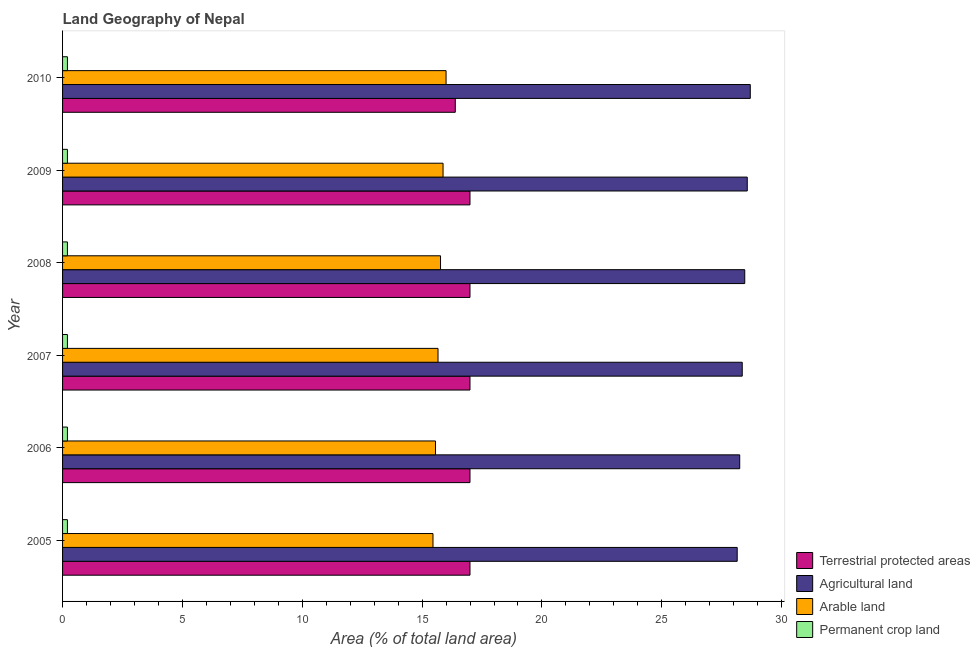How many different coloured bars are there?
Offer a very short reply. 4. Are the number of bars per tick equal to the number of legend labels?
Your answer should be very brief. Yes. Are the number of bars on each tick of the Y-axis equal?
Give a very brief answer. Yes. In how many cases, is the number of bars for a given year not equal to the number of legend labels?
Offer a very short reply. 0. What is the percentage of area under agricultural land in 2009?
Your response must be concise. 28.57. Across all years, what is the maximum percentage of area under permanent crop land?
Provide a succinct answer. 0.2. Across all years, what is the minimum percentage of area under arable land?
Your answer should be very brief. 15.45. In which year was the percentage of area under agricultural land maximum?
Your answer should be very brief. 2010. In which year was the percentage of area under arable land minimum?
Your answer should be very brief. 2005. What is the total percentage of land under terrestrial protection in the graph?
Keep it short and to the point. 101.37. What is the difference between the percentage of area under permanent crop land in 2005 and that in 2009?
Your response must be concise. 0. What is the difference between the percentage of area under agricultural land in 2010 and the percentage of area under arable land in 2009?
Your answer should be compact. 12.82. What is the average percentage of area under agricultural land per year?
Your answer should be compact. 28.41. In the year 2006, what is the difference between the percentage of area under agricultural land and percentage of area under permanent crop land?
Provide a short and direct response. 28.05. Is the percentage of area under agricultural land in 2005 less than that in 2010?
Give a very brief answer. Yes. Is the difference between the percentage of land under terrestrial protection in 2007 and 2009 greater than the difference between the percentage of area under agricultural land in 2007 and 2009?
Make the answer very short. Yes. What is the difference between the highest and the second highest percentage of area under agricultural land?
Give a very brief answer. 0.13. What is the difference between the highest and the lowest percentage of land under terrestrial protection?
Your answer should be very brief. 0.61. What does the 3rd bar from the top in 2006 represents?
Offer a very short reply. Agricultural land. What does the 2nd bar from the bottom in 2007 represents?
Keep it short and to the point. Agricultural land. How many bars are there?
Keep it short and to the point. 24. How many years are there in the graph?
Your answer should be very brief. 6. What is the difference between two consecutive major ticks on the X-axis?
Give a very brief answer. 5. Does the graph contain grids?
Provide a succinct answer. No. How are the legend labels stacked?
Make the answer very short. Vertical. What is the title of the graph?
Provide a succinct answer. Land Geography of Nepal. Does "Burnt food" appear as one of the legend labels in the graph?
Offer a very short reply. No. What is the label or title of the X-axis?
Your answer should be compact. Area (% of total land area). What is the label or title of the Y-axis?
Offer a very short reply. Year. What is the Area (% of total land area) in Terrestrial protected areas in 2005?
Your answer should be very brief. 17. What is the Area (% of total land area) in Agricultural land in 2005?
Your answer should be very brief. 28.15. What is the Area (% of total land area) of Arable land in 2005?
Offer a very short reply. 15.45. What is the Area (% of total land area) of Permanent crop land in 2005?
Offer a very short reply. 0.2. What is the Area (% of total land area) in Terrestrial protected areas in 2006?
Make the answer very short. 17. What is the Area (% of total land area) of Agricultural land in 2006?
Your answer should be very brief. 28.25. What is the Area (% of total land area) in Arable land in 2006?
Ensure brevity in your answer.  15.56. What is the Area (% of total land area) of Permanent crop land in 2006?
Ensure brevity in your answer.  0.2. What is the Area (% of total land area) in Terrestrial protected areas in 2007?
Ensure brevity in your answer.  17. What is the Area (% of total land area) in Agricultural land in 2007?
Your response must be concise. 28.36. What is the Area (% of total land area) in Arable land in 2007?
Offer a very short reply. 15.66. What is the Area (% of total land area) in Permanent crop land in 2007?
Your answer should be very brief. 0.2. What is the Area (% of total land area) in Terrestrial protected areas in 2008?
Provide a succinct answer. 17. What is the Area (% of total land area) in Agricultural land in 2008?
Make the answer very short. 28.46. What is the Area (% of total land area) in Arable land in 2008?
Provide a short and direct response. 15.77. What is the Area (% of total land area) in Permanent crop land in 2008?
Offer a terse response. 0.2. What is the Area (% of total land area) of Terrestrial protected areas in 2009?
Provide a short and direct response. 17. What is the Area (% of total land area) in Agricultural land in 2009?
Provide a succinct answer. 28.57. What is the Area (% of total land area) of Arable land in 2009?
Offer a very short reply. 15.87. What is the Area (% of total land area) in Permanent crop land in 2009?
Ensure brevity in your answer.  0.2. What is the Area (% of total land area) of Terrestrial protected areas in 2010?
Make the answer very short. 16.38. What is the Area (% of total land area) of Agricultural land in 2010?
Your response must be concise. 28.69. What is the Area (% of total land area) in Arable land in 2010?
Your answer should be compact. 16. What is the Area (% of total land area) of Permanent crop land in 2010?
Make the answer very short. 0.2. Across all years, what is the maximum Area (% of total land area) of Terrestrial protected areas?
Make the answer very short. 17. Across all years, what is the maximum Area (% of total land area) of Agricultural land?
Offer a very short reply. 28.69. Across all years, what is the maximum Area (% of total land area) in Permanent crop land?
Your response must be concise. 0.2. Across all years, what is the minimum Area (% of total land area) in Terrestrial protected areas?
Provide a short and direct response. 16.38. Across all years, what is the minimum Area (% of total land area) of Agricultural land?
Ensure brevity in your answer.  28.15. Across all years, what is the minimum Area (% of total land area) of Arable land?
Provide a short and direct response. 15.45. Across all years, what is the minimum Area (% of total land area) in Permanent crop land?
Offer a terse response. 0.2. What is the total Area (% of total land area) in Terrestrial protected areas in the graph?
Your answer should be compact. 101.37. What is the total Area (% of total land area) of Agricultural land in the graph?
Make the answer very short. 170.48. What is the total Area (% of total land area) of Arable land in the graph?
Give a very brief answer. 94.32. What is the total Area (% of total land area) in Permanent crop land in the graph?
Ensure brevity in your answer.  1.22. What is the difference between the Area (% of total land area) of Terrestrial protected areas in 2005 and that in 2006?
Offer a terse response. 0. What is the difference between the Area (% of total land area) of Agricultural land in 2005 and that in 2006?
Provide a short and direct response. -0.1. What is the difference between the Area (% of total land area) of Arable land in 2005 and that in 2006?
Your answer should be very brief. -0.1. What is the difference between the Area (% of total land area) in Permanent crop land in 2005 and that in 2006?
Ensure brevity in your answer.  0. What is the difference between the Area (% of total land area) in Terrestrial protected areas in 2005 and that in 2007?
Your answer should be compact. 0. What is the difference between the Area (% of total land area) in Agricultural land in 2005 and that in 2007?
Give a very brief answer. -0.21. What is the difference between the Area (% of total land area) of Arable land in 2005 and that in 2007?
Offer a terse response. -0.21. What is the difference between the Area (% of total land area) of Permanent crop land in 2005 and that in 2007?
Give a very brief answer. 0. What is the difference between the Area (% of total land area) of Terrestrial protected areas in 2005 and that in 2008?
Offer a very short reply. 0. What is the difference between the Area (% of total land area) in Agricultural land in 2005 and that in 2008?
Give a very brief answer. -0.31. What is the difference between the Area (% of total land area) in Arable land in 2005 and that in 2008?
Make the answer very short. -0.31. What is the difference between the Area (% of total land area) in Permanent crop land in 2005 and that in 2008?
Give a very brief answer. 0. What is the difference between the Area (% of total land area) in Terrestrial protected areas in 2005 and that in 2009?
Offer a very short reply. 0. What is the difference between the Area (% of total land area) in Agricultural land in 2005 and that in 2009?
Give a very brief answer. -0.42. What is the difference between the Area (% of total land area) in Arable land in 2005 and that in 2009?
Your answer should be compact. -0.42. What is the difference between the Area (% of total land area) of Terrestrial protected areas in 2005 and that in 2010?
Your answer should be very brief. 0.61. What is the difference between the Area (% of total land area) in Agricultural land in 2005 and that in 2010?
Ensure brevity in your answer.  -0.55. What is the difference between the Area (% of total land area) in Arable land in 2005 and that in 2010?
Your answer should be compact. -0.55. What is the difference between the Area (% of total land area) of Permanent crop land in 2005 and that in 2010?
Your answer should be very brief. 0. What is the difference between the Area (% of total land area) in Agricultural land in 2006 and that in 2007?
Ensure brevity in your answer.  -0.1. What is the difference between the Area (% of total land area) of Arable land in 2006 and that in 2007?
Your answer should be compact. -0.1. What is the difference between the Area (% of total land area) in Permanent crop land in 2006 and that in 2007?
Offer a terse response. 0. What is the difference between the Area (% of total land area) in Terrestrial protected areas in 2006 and that in 2008?
Ensure brevity in your answer.  0. What is the difference between the Area (% of total land area) in Agricultural land in 2006 and that in 2008?
Your answer should be very brief. -0.21. What is the difference between the Area (% of total land area) in Arable land in 2006 and that in 2008?
Your answer should be compact. -0.21. What is the difference between the Area (% of total land area) of Terrestrial protected areas in 2006 and that in 2009?
Your answer should be compact. 0. What is the difference between the Area (% of total land area) in Agricultural land in 2006 and that in 2009?
Offer a very short reply. -0.31. What is the difference between the Area (% of total land area) of Arable land in 2006 and that in 2009?
Your response must be concise. -0.31. What is the difference between the Area (% of total land area) in Terrestrial protected areas in 2006 and that in 2010?
Your answer should be compact. 0.61. What is the difference between the Area (% of total land area) of Agricultural land in 2006 and that in 2010?
Make the answer very short. -0.44. What is the difference between the Area (% of total land area) of Arable land in 2006 and that in 2010?
Your answer should be very brief. -0.44. What is the difference between the Area (% of total land area) of Permanent crop land in 2006 and that in 2010?
Offer a terse response. 0. What is the difference between the Area (% of total land area) of Terrestrial protected areas in 2007 and that in 2008?
Your answer should be compact. 0. What is the difference between the Area (% of total land area) in Agricultural land in 2007 and that in 2008?
Make the answer very short. -0.1. What is the difference between the Area (% of total land area) in Arable land in 2007 and that in 2008?
Your response must be concise. -0.1. What is the difference between the Area (% of total land area) of Agricultural land in 2007 and that in 2009?
Offer a very short reply. -0.21. What is the difference between the Area (% of total land area) of Arable land in 2007 and that in 2009?
Your answer should be very brief. -0.21. What is the difference between the Area (% of total land area) in Terrestrial protected areas in 2007 and that in 2010?
Provide a succinct answer. 0.61. What is the difference between the Area (% of total land area) in Agricultural land in 2007 and that in 2010?
Offer a very short reply. -0.34. What is the difference between the Area (% of total land area) in Arable land in 2007 and that in 2010?
Your answer should be compact. -0.34. What is the difference between the Area (% of total land area) in Terrestrial protected areas in 2008 and that in 2009?
Make the answer very short. 0. What is the difference between the Area (% of total land area) in Agricultural land in 2008 and that in 2009?
Provide a short and direct response. -0.1. What is the difference between the Area (% of total land area) in Arable land in 2008 and that in 2009?
Offer a very short reply. -0.1. What is the difference between the Area (% of total land area) in Terrestrial protected areas in 2008 and that in 2010?
Give a very brief answer. 0.61. What is the difference between the Area (% of total land area) in Agricultural land in 2008 and that in 2010?
Provide a short and direct response. -0.23. What is the difference between the Area (% of total land area) in Arable land in 2008 and that in 2010?
Your response must be concise. -0.23. What is the difference between the Area (% of total land area) in Permanent crop land in 2008 and that in 2010?
Offer a terse response. 0. What is the difference between the Area (% of total land area) of Terrestrial protected areas in 2009 and that in 2010?
Your answer should be compact. 0.61. What is the difference between the Area (% of total land area) of Agricultural land in 2009 and that in 2010?
Keep it short and to the point. -0.13. What is the difference between the Area (% of total land area) of Arable land in 2009 and that in 2010?
Give a very brief answer. -0.13. What is the difference between the Area (% of total land area) of Permanent crop land in 2009 and that in 2010?
Your response must be concise. 0. What is the difference between the Area (% of total land area) in Terrestrial protected areas in 2005 and the Area (% of total land area) in Agricultural land in 2006?
Keep it short and to the point. -11.25. What is the difference between the Area (% of total land area) in Terrestrial protected areas in 2005 and the Area (% of total land area) in Arable land in 2006?
Your response must be concise. 1.44. What is the difference between the Area (% of total land area) of Terrestrial protected areas in 2005 and the Area (% of total land area) of Permanent crop land in 2006?
Offer a terse response. 16.8. What is the difference between the Area (% of total land area) of Agricultural land in 2005 and the Area (% of total land area) of Arable land in 2006?
Make the answer very short. 12.59. What is the difference between the Area (% of total land area) in Agricultural land in 2005 and the Area (% of total land area) in Permanent crop land in 2006?
Provide a short and direct response. 27.94. What is the difference between the Area (% of total land area) of Arable land in 2005 and the Area (% of total land area) of Permanent crop land in 2006?
Offer a very short reply. 15.25. What is the difference between the Area (% of total land area) of Terrestrial protected areas in 2005 and the Area (% of total land area) of Agricultural land in 2007?
Ensure brevity in your answer.  -11.36. What is the difference between the Area (% of total land area) of Terrestrial protected areas in 2005 and the Area (% of total land area) of Arable land in 2007?
Ensure brevity in your answer.  1.33. What is the difference between the Area (% of total land area) of Terrestrial protected areas in 2005 and the Area (% of total land area) of Permanent crop land in 2007?
Provide a short and direct response. 16.8. What is the difference between the Area (% of total land area) of Agricultural land in 2005 and the Area (% of total land area) of Arable land in 2007?
Give a very brief answer. 12.48. What is the difference between the Area (% of total land area) of Agricultural land in 2005 and the Area (% of total land area) of Permanent crop land in 2007?
Keep it short and to the point. 27.94. What is the difference between the Area (% of total land area) in Arable land in 2005 and the Area (% of total land area) in Permanent crop land in 2007?
Provide a succinct answer. 15.25. What is the difference between the Area (% of total land area) in Terrestrial protected areas in 2005 and the Area (% of total land area) in Agricultural land in 2008?
Offer a terse response. -11.46. What is the difference between the Area (% of total land area) of Terrestrial protected areas in 2005 and the Area (% of total land area) of Arable land in 2008?
Your answer should be compact. 1.23. What is the difference between the Area (% of total land area) of Terrestrial protected areas in 2005 and the Area (% of total land area) of Permanent crop land in 2008?
Ensure brevity in your answer.  16.8. What is the difference between the Area (% of total land area) of Agricultural land in 2005 and the Area (% of total land area) of Arable land in 2008?
Your answer should be compact. 12.38. What is the difference between the Area (% of total land area) in Agricultural land in 2005 and the Area (% of total land area) in Permanent crop land in 2008?
Ensure brevity in your answer.  27.94. What is the difference between the Area (% of total land area) in Arable land in 2005 and the Area (% of total land area) in Permanent crop land in 2008?
Your answer should be compact. 15.25. What is the difference between the Area (% of total land area) of Terrestrial protected areas in 2005 and the Area (% of total land area) of Agricultural land in 2009?
Your answer should be compact. -11.57. What is the difference between the Area (% of total land area) of Terrestrial protected areas in 2005 and the Area (% of total land area) of Arable land in 2009?
Offer a terse response. 1.12. What is the difference between the Area (% of total land area) of Terrestrial protected areas in 2005 and the Area (% of total land area) of Permanent crop land in 2009?
Offer a very short reply. 16.8. What is the difference between the Area (% of total land area) in Agricultural land in 2005 and the Area (% of total land area) in Arable land in 2009?
Your response must be concise. 12.27. What is the difference between the Area (% of total land area) of Agricultural land in 2005 and the Area (% of total land area) of Permanent crop land in 2009?
Ensure brevity in your answer.  27.94. What is the difference between the Area (% of total land area) in Arable land in 2005 and the Area (% of total land area) in Permanent crop land in 2009?
Offer a terse response. 15.25. What is the difference between the Area (% of total land area) of Terrestrial protected areas in 2005 and the Area (% of total land area) of Agricultural land in 2010?
Make the answer very short. -11.69. What is the difference between the Area (% of total land area) of Terrestrial protected areas in 2005 and the Area (% of total land area) of Arable land in 2010?
Offer a terse response. 1. What is the difference between the Area (% of total land area) of Terrestrial protected areas in 2005 and the Area (% of total land area) of Permanent crop land in 2010?
Ensure brevity in your answer.  16.8. What is the difference between the Area (% of total land area) in Agricultural land in 2005 and the Area (% of total land area) in Arable land in 2010?
Provide a short and direct response. 12.15. What is the difference between the Area (% of total land area) in Agricultural land in 2005 and the Area (% of total land area) in Permanent crop land in 2010?
Your answer should be compact. 27.94. What is the difference between the Area (% of total land area) in Arable land in 2005 and the Area (% of total land area) in Permanent crop land in 2010?
Provide a short and direct response. 15.25. What is the difference between the Area (% of total land area) in Terrestrial protected areas in 2006 and the Area (% of total land area) in Agricultural land in 2007?
Give a very brief answer. -11.36. What is the difference between the Area (% of total land area) of Terrestrial protected areas in 2006 and the Area (% of total land area) of Arable land in 2007?
Offer a very short reply. 1.33. What is the difference between the Area (% of total land area) of Terrestrial protected areas in 2006 and the Area (% of total land area) of Permanent crop land in 2007?
Provide a short and direct response. 16.8. What is the difference between the Area (% of total land area) of Agricultural land in 2006 and the Area (% of total land area) of Arable land in 2007?
Your response must be concise. 12.59. What is the difference between the Area (% of total land area) in Agricultural land in 2006 and the Area (% of total land area) in Permanent crop land in 2007?
Your response must be concise. 28.05. What is the difference between the Area (% of total land area) in Arable land in 2006 and the Area (% of total land area) in Permanent crop land in 2007?
Make the answer very short. 15.36. What is the difference between the Area (% of total land area) of Terrestrial protected areas in 2006 and the Area (% of total land area) of Agricultural land in 2008?
Offer a very short reply. -11.46. What is the difference between the Area (% of total land area) in Terrestrial protected areas in 2006 and the Area (% of total land area) in Arable land in 2008?
Provide a succinct answer. 1.23. What is the difference between the Area (% of total land area) in Terrestrial protected areas in 2006 and the Area (% of total land area) in Permanent crop land in 2008?
Provide a succinct answer. 16.8. What is the difference between the Area (% of total land area) of Agricultural land in 2006 and the Area (% of total land area) of Arable land in 2008?
Your answer should be compact. 12.48. What is the difference between the Area (% of total land area) of Agricultural land in 2006 and the Area (% of total land area) of Permanent crop land in 2008?
Give a very brief answer. 28.05. What is the difference between the Area (% of total land area) in Arable land in 2006 and the Area (% of total land area) in Permanent crop land in 2008?
Give a very brief answer. 15.36. What is the difference between the Area (% of total land area) in Terrestrial protected areas in 2006 and the Area (% of total land area) in Agricultural land in 2009?
Provide a succinct answer. -11.57. What is the difference between the Area (% of total land area) in Terrestrial protected areas in 2006 and the Area (% of total land area) in Arable land in 2009?
Provide a short and direct response. 1.12. What is the difference between the Area (% of total land area) in Terrestrial protected areas in 2006 and the Area (% of total land area) in Permanent crop land in 2009?
Your answer should be very brief. 16.8. What is the difference between the Area (% of total land area) in Agricultural land in 2006 and the Area (% of total land area) in Arable land in 2009?
Ensure brevity in your answer.  12.38. What is the difference between the Area (% of total land area) in Agricultural land in 2006 and the Area (% of total land area) in Permanent crop land in 2009?
Make the answer very short. 28.05. What is the difference between the Area (% of total land area) of Arable land in 2006 and the Area (% of total land area) of Permanent crop land in 2009?
Ensure brevity in your answer.  15.36. What is the difference between the Area (% of total land area) in Terrestrial protected areas in 2006 and the Area (% of total land area) in Agricultural land in 2010?
Make the answer very short. -11.69. What is the difference between the Area (% of total land area) of Terrestrial protected areas in 2006 and the Area (% of total land area) of Arable land in 2010?
Offer a terse response. 1. What is the difference between the Area (% of total land area) in Terrestrial protected areas in 2006 and the Area (% of total land area) in Permanent crop land in 2010?
Offer a very short reply. 16.8. What is the difference between the Area (% of total land area) in Agricultural land in 2006 and the Area (% of total land area) in Arable land in 2010?
Offer a terse response. 12.25. What is the difference between the Area (% of total land area) of Agricultural land in 2006 and the Area (% of total land area) of Permanent crop land in 2010?
Give a very brief answer. 28.05. What is the difference between the Area (% of total land area) in Arable land in 2006 and the Area (% of total land area) in Permanent crop land in 2010?
Offer a very short reply. 15.36. What is the difference between the Area (% of total land area) of Terrestrial protected areas in 2007 and the Area (% of total land area) of Agricultural land in 2008?
Keep it short and to the point. -11.46. What is the difference between the Area (% of total land area) in Terrestrial protected areas in 2007 and the Area (% of total land area) in Arable land in 2008?
Your response must be concise. 1.23. What is the difference between the Area (% of total land area) in Terrestrial protected areas in 2007 and the Area (% of total land area) in Permanent crop land in 2008?
Offer a very short reply. 16.8. What is the difference between the Area (% of total land area) of Agricultural land in 2007 and the Area (% of total land area) of Arable land in 2008?
Make the answer very short. 12.59. What is the difference between the Area (% of total land area) in Agricultural land in 2007 and the Area (% of total land area) in Permanent crop land in 2008?
Give a very brief answer. 28.15. What is the difference between the Area (% of total land area) of Arable land in 2007 and the Area (% of total land area) of Permanent crop land in 2008?
Your answer should be compact. 15.46. What is the difference between the Area (% of total land area) of Terrestrial protected areas in 2007 and the Area (% of total land area) of Agricultural land in 2009?
Your answer should be compact. -11.57. What is the difference between the Area (% of total land area) of Terrestrial protected areas in 2007 and the Area (% of total land area) of Arable land in 2009?
Keep it short and to the point. 1.12. What is the difference between the Area (% of total land area) in Terrestrial protected areas in 2007 and the Area (% of total land area) in Permanent crop land in 2009?
Offer a terse response. 16.8. What is the difference between the Area (% of total land area) of Agricultural land in 2007 and the Area (% of total land area) of Arable land in 2009?
Provide a succinct answer. 12.48. What is the difference between the Area (% of total land area) in Agricultural land in 2007 and the Area (% of total land area) in Permanent crop land in 2009?
Offer a terse response. 28.15. What is the difference between the Area (% of total land area) of Arable land in 2007 and the Area (% of total land area) of Permanent crop land in 2009?
Provide a succinct answer. 15.46. What is the difference between the Area (% of total land area) of Terrestrial protected areas in 2007 and the Area (% of total land area) of Agricultural land in 2010?
Your answer should be very brief. -11.69. What is the difference between the Area (% of total land area) of Terrestrial protected areas in 2007 and the Area (% of total land area) of Arable land in 2010?
Offer a very short reply. 1. What is the difference between the Area (% of total land area) in Terrestrial protected areas in 2007 and the Area (% of total land area) in Permanent crop land in 2010?
Your answer should be compact. 16.8. What is the difference between the Area (% of total land area) in Agricultural land in 2007 and the Area (% of total land area) in Arable land in 2010?
Offer a very short reply. 12.36. What is the difference between the Area (% of total land area) in Agricultural land in 2007 and the Area (% of total land area) in Permanent crop land in 2010?
Provide a short and direct response. 28.15. What is the difference between the Area (% of total land area) in Arable land in 2007 and the Area (% of total land area) in Permanent crop land in 2010?
Your answer should be very brief. 15.46. What is the difference between the Area (% of total land area) of Terrestrial protected areas in 2008 and the Area (% of total land area) of Agricultural land in 2009?
Give a very brief answer. -11.57. What is the difference between the Area (% of total land area) of Terrestrial protected areas in 2008 and the Area (% of total land area) of Arable land in 2009?
Your answer should be very brief. 1.12. What is the difference between the Area (% of total land area) in Terrestrial protected areas in 2008 and the Area (% of total land area) in Permanent crop land in 2009?
Give a very brief answer. 16.8. What is the difference between the Area (% of total land area) of Agricultural land in 2008 and the Area (% of total land area) of Arable land in 2009?
Provide a succinct answer. 12.59. What is the difference between the Area (% of total land area) of Agricultural land in 2008 and the Area (% of total land area) of Permanent crop land in 2009?
Make the answer very short. 28.26. What is the difference between the Area (% of total land area) in Arable land in 2008 and the Area (% of total land area) in Permanent crop land in 2009?
Keep it short and to the point. 15.57. What is the difference between the Area (% of total land area) of Terrestrial protected areas in 2008 and the Area (% of total land area) of Agricultural land in 2010?
Provide a short and direct response. -11.69. What is the difference between the Area (% of total land area) of Terrestrial protected areas in 2008 and the Area (% of total land area) of Arable land in 2010?
Provide a succinct answer. 1. What is the difference between the Area (% of total land area) of Terrestrial protected areas in 2008 and the Area (% of total land area) of Permanent crop land in 2010?
Your answer should be compact. 16.8. What is the difference between the Area (% of total land area) in Agricultural land in 2008 and the Area (% of total land area) in Arable land in 2010?
Your answer should be very brief. 12.46. What is the difference between the Area (% of total land area) in Agricultural land in 2008 and the Area (% of total land area) in Permanent crop land in 2010?
Your answer should be very brief. 28.26. What is the difference between the Area (% of total land area) in Arable land in 2008 and the Area (% of total land area) in Permanent crop land in 2010?
Your response must be concise. 15.57. What is the difference between the Area (% of total land area) of Terrestrial protected areas in 2009 and the Area (% of total land area) of Agricultural land in 2010?
Make the answer very short. -11.69. What is the difference between the Area (% of total land area) of Terrestrial protected areas in 2009 and the Area (% of total land area) of Arable land in 2010?
Give a very brief answer. 1. What is the difference between the Area (% of total land area) in Terrestrial protected areas in 2009 and the Area (% of total land area) in Permanent crop land in 2010?
Your answer should be very brief. 16.8. What is the difference between the Area (% of total land area) in Agricultural land in 2009 and the Area (% of total land area) in Arable land in 2010?
Your response must be concise. 12.57. What is the difference between the Area (% of total land area) of Agricultural land in 2009 and the Area (% of total land area) of Permanent crop land in 2010?
Your answer should be compact. 28.36. What is the difference between the Area (% of total land area) of Arable land in 2009 and the Area (% of total land area) of Permanent crop land in 2010?
Provide a succinct answer. 15.67. What is the average Area (% of total land area) of Terrestrial protected areas per year?
Your answer should be compact. 16.9. What is the average Area (% of total land area) of Agricultural land per year?
Your answer should be compact. 28.41. What is the average Area (% of total land area) in Arable land per year?
Provide a short and direct response. 15.72. What is the average Area (% of total land area) in Permanent crop land per year?
Make the answer very short. 0.2. In the year 2005, what is the difference between the Area (% of total land area) in Terrestrial protected areas and Area (% of total land area) in Agricultural land?
Offer a very short reply. -11.15. In the year 2005, what is the difference between the Area (% of total land area) of Terrestrial protected areas and Area (% of total land area) of Arable land?
Offer a terse response. 1.54. In the year 2005, what is the difference between the Area (% of total land area) of Terrestrial protected areas and Area (% of total land area) of Permanent crop land?
Offer a very short reply. 16.8. In the year 2005, what is the difference between the Area (% of total land area) in Agricultural land and Area (% of total land area) in Arable land?
Provide a short and direct response. 12.69. In the year 2005, what is the difference between the Area (% of total land area) of Agricultural land and Area (% of total land area) of Permanent crop land?
Offer a terse response. 27.94. In the year 2005, what is the difference between the Area (% of total land area) in Arable land and Area (% of total land area) in Permanent crop land?
Make the answer very short. 15.25. In the year 2006, what is the difference between the Area (% of total land area) in Terrestrial protected areas and Area (% of total land area) in Agricultural land?
Your answer should be very brief. -11.25. In the year 2006, what is the difference between the Area (% of total land area) in Terrestrial protected areas and Area (% of total land area) in Arable land?
Offer a terse response. 1.44. In the year 2006, what is the difference between the Area (% of total land area) in Terrestrial protected areas and Area (% of total land area) in Permanent crop land?
Your answer should be compact. 16.8. In the year 2006, what is the difference between the Area (% of total land area) in Agricultural land and Area (% of total land area) in Arable land?
Give a very brief answer. 12.69. In the year 2006, what is the difference between the Area (% of total land area) of Agricultural land and Area (% of total land area) of Permanent crop land?
Your answer should be very brief. 28.05. In the year 2006, what is the difference between the Area (% of total land area) of Arable land and Area (% of total land area) of Permanent crop land?
Make the answer very short. 15.36. In the year 2007, what is the difference between the Area (% of total land area) in Terrestrial protected areas and Area (% of total land area) in Agricultural land?
Offer a terse response. -11.36. In the year 2007, what is the difference between the Area (% of total land area) in Terrestrial protected areas and Area (% of total land area) in Arable land?
Offer a terse response. 1.33. In the year 2007, what is the difference between the Area (% of total land area) in Terrestrial protected areas and Area (% of total land area) in Permanent crop land?
Give a very brief answer. 16.8. In the year 2007, what is the difference between the Area (% of total land area) of Agricultural land and Area (% of total land area) of Arable land?
Provide a short and direct response. 12.69. In the year 2007, what is the difference between the Area (% of total land area) in Agricultural land and Area (% of total land area) in Permanent crop land?
Your answer should be very brief. 28.15. In the year 2007, what is the difference between the Area (% of total land area) of Arable land and Area (% of total land area) of Permanent crop land?
Your response must be concise. 15.46. In the year 2008, what is the difference between the Area (% of total land area) in Terrestrial protected areas and Area (% of total land area) in Agricultural land?
Offer a terse response. -11.46. In the year 2008, what is the difference between the Area (% of total land area) in Terrestrial protected areas and Area (% of total land area) in Arable land?
Offer a very short reply. 1.23. In the year 2008, what is the difference between the Area (% of total land area) in Terrestrial protected areas and Area (% of total land area) in Permanent crop land?
Ensure brevity in your answer.  16.8. In the year 2008, what is the difference between the Area (% of total land area) of Agricultural land and Area (% of total land area) of Arable land?
Provide a succinct answer. 12.69. In the year 2008, what is the difference between the Area (% of total land area) in Agricultural land and Area (% of total land area) in Permanent crop land?
Offer a very short reply. 28.26. In the year 2008, what is the difference between the Area (% of total land area) in Arable land and Area (% of total land area) in Permanent crop land?
Keep it short and to the point. 15.57. In the year 2009, what is the difference between the Area (% of total land area) of Terrestrial protected areas and Area (% of total land area) of Agricultural land?
Ensure brevity in your answer.  -11.57. In the year 2009, what is the difference between the Area (% of total land area) of Terrestrial protected areas and Area (% of total land area) of Arable land?
Keep it short and to the point. 1.12. In the year 2009, what is the difference between the Area (% of total land area) in Terrestrial protected areas and Area (% of total land area) in Permanent crop land?
Provide a succinct answer. 16.8. In the year 2009, what is the difference between the Area (% of total land area) in Agricultural land and Area (% of total land area) in Arable land?
Offer a very short reply. 12.69. In the year 2009, what is the difference between the Area (% of total land area) of Agricultural land and Area (% of total land area) of Permanent crop land?
Make the answer very short. 28.36. In the year 2009, what is the difference between the Area (% of total land area) in Arable land and Area (% of total land area) in Permanent crop land?
Provide a succinct answer. 15.67. In the year 2010, what is the difference between the Area (% of total land area) of Terrestrial protected areas and Area (% of total land area) of Agricultural land?
Your answer should be compact. -12.31. In the year 2010, what is the difference between the Area (% of total land area) in Terrestrial protected areas and Area (% of total land area) in Arable land?
Provide a succinct answer. 0.38. In the year 2010, what is the difference between the Area (% of total land area) of Terrestrial protected areas and Area (% of total land area) of Permanent crop land?
Give a very brief answer. 16.18. In the year 2010, what is the difference between the Area (% of total land area) in Agricultural land and Area (% of total land area) in Arable land?
Make the answer very short. 12.69. In the year 2010, what is the difference between the Area (% of total land area) of Agricultural land and Area (% of total land area) of Permanent crop land?
Keep it short and to the point. 28.49. In the year 2010, what is the difference between the Area (% of total land area) of Arable land and Area (% of total land area) of Permanent crop land?
Provide a short and direct response. 15.8. What is the ratio of the Area (% of total land area) of Agricultural land in 2005 to that in 2006?
Make the answer very short. 1. What is the ratio of the Area (% of total land area) in Terrestrial protected areas in 2005 to that in 2007?
Ensure brevity in your answer.  1. What is the ratio of the Area (% of total land area) of Agricultural land in 2005 to that in 2007?
Give a very brief answer. 0.99. What is the ratio of the Area (% of total land area) in Arable land in 2005 to that in 2007?
Your response must be concise. 0.99. What is the ratio of the Area (% of total land area) in Agricultural land in 2005 to that in 2008?
Keep it short and to the point. 0.99. What is the ratio of the Area (% of total land area) in Permanent crop land in 2005 to that in 2008?
Ensure brevity in your answer.  1. What is the ratio of the Area (% of total land area) in Terrestrial protected areas in 2005 to that in 2009?
Your answer should be compact. 1. What is the ratio of the Area (% of total land area) of Arable land in 2005 to that in 2009?
Your answer should be compact. 0.97. What is the ratio of the Area (% of total land area) in Terrestrial protected areas in 2005 to that in 2010?
Provide a succinct answer. 1.04. What is the ratio of the Area (% of total land area) of Arable land in 2005 to that in 2010?
Ensure brevity in your answer.  0.97. What is the ratio of the Area (% of total land area) in Permanent crop land in 2005 to that in 2010?
Provide a succinct answer. 1. What is the ratio of the Area (% of total land area) in Arable land in 2006 to that in 2007?
Give a very brief answer. 0.99. What is the ratio of the Area (% of total land area) in Permanent crop land in 2006 to that in 2007?
Keep it short and to the point. 1. What is the ratio of the Area (% of total land area) of Terrestrial protected areas in 2006 to that in 2008?
Keep it short and to the point. 1. What is the ratio of the Area (% of total land area) in Agricultural land in 2006 to that in 2008?
Provide a short and direct response. 0.99. What is the ratio of the Area (% of total land area) in Arable land in 2006 to that in 2008?
Your response must be concise. 0.99. What is the ratio of the Area (% of total land area) in Permanent crop land in 2006 to that in 2008?
Offer a terse response. 1. What is the ratio of the Area (% of total land area) in Terrestrial protected areas in 2006 to that in 2009?
Provide a succinct answer. 1. What is the ratio of the Area (% of total land area) in Agricultural land in 2006 to that in 2009?
Provide a short and direct response. 0.99. What is the ratio of the Area (% of total land area) in Arable land in 2006 to that in 2009?
Provide a short and direct response. 0.98. What is the ratio of the Area (% of total land area) of Permanent crop land in 2006 to that in 2009?
Provide a short and direct response. 1. What is the ratio of the Area (% of total land area) of Terrestrial protected areas in 2006 to that in 2010?
Offer a very short reply. 1.04. What is the ratio of the Area (% of total land area) in Agricultural land in 2006 to that in 2010?
Ensure brevity in your answer.  0.98. What is the ratio of the Area (% of total land area) in Arable land in 2006 to that in 2010?
Make the answer very short. 0.97. What is the ratio of the Area (% of total land area) of Permanent crop land in 2006 to that in 2010?
Keep it short and to the point. 1. What is the ratio of the Area (% of total land area) in Agricultural land in 2007 to that in 2008?
Provide a succinct answer. 1. What is the ratio of the Area (% of total land area) of Arable land in 2007 to that in 2009?
Ensure brevity in your answer.  0.99. What is the ratio of the Area (% of total land area) of Terrestrial protected areas in 2007 to that in 2010?
Your response must be concise. 1.04. What is the ratio of the Area (% of total land area) in Agricultural land in 2007 to that in 2010?
Ensure brevity in your answer.  0.99. What is the ratio of the Area (% of total land area) of Agricultural land in 2008 to that in 2009?
Make the answer very short. 1. What is the ratio of the Area (% of total land area) of Arable land in 2008 to that in 2009?
Provide a short and direct response. 0.99. What is the ratio of the Area (% of total land area) in Permanent crop land in 2008 to that in 2009?
Provide a succinct answer. 1. What is the ratio of the Area (% of total land area) in Terrestrial protected areas in 2008 to that in 2010?
Offer a terse response. 1.04. What is the ratio of the Area (% of total land area) in Agricultural land in 2008 to that in 2010?
Keep it short and to the point. 0.99. What is the ratio of the Area (% of total land area) of Arable land in 2008 to that in 2010?
Offer a very short reply. 0.99. What is the ratio of the Area (% of total land area) in Terrestrial protected areas in 2009 to that in 2010?
Make the answer very short. 1.04. What is the difference between the highest and the second highest Area (% of total land area) of Terrestrial protected areas?
Your answer should be very brief. 0. What is the difference between the highest and the second highest Area (% of total land area) in Agricultural land?
Keep it short and to the point. 0.13. What is the difference between the highest and the second highest Area (% of total land area) of Arable land?
Keep it short and to the point. 0.13. What is the difference between the highest and the second highest Area (% of total land area) in Permanent crop land?
Your answer should be compact. 0. What is the difference between the highest and the lowest Area (% of total land area) in Terrestrial protected areas?
Keep it short and to the point. 0.61. What is the difference between the highest and the lowest Area (% of total land area) of Agricultural land?
Give a very brief answer. 0.55. What is the difference between the highest and the lowest Area (% of total land area) of Arable land?
Provide a succinct answer. 0.55. What is the difference between the highest and the lowest Area (% of total land area) in Permanent crop land?
Make the answer very short. 0. 